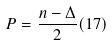Convert formula to latex. <formula><loc_0><loc_0><loc_500><loc_500>P = \frac { n - \Delta } { 2 } ( 1 7 )</formula> 